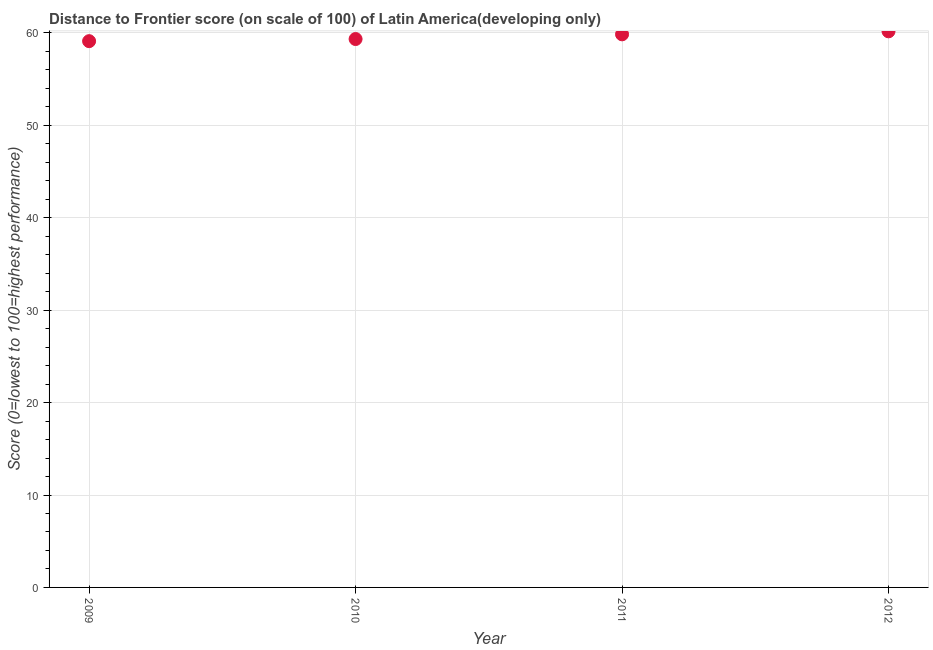What is the distance to frontier score in 2009?
Your answer should be compact. 59.11. Across all years, what is the maximum distance to frontier score?
Your answer should be very brief. 60.17. Across all years, what is the minimum distance to frontier score?
Give a very brief answer. 59.11. In which year was the distance to frontier score minimum?
Provide a short and direct response. 2009. What is the sum of the distance to frontier score?
Your answer should be very brief. 238.46. What is the difference between the distance to frontier score in 2011 and 2012?
Ensure brevity in your answer.  -0.33. What is the average distance to frontier score per year?
Your answer should be compact. 59.62. What is the median distance to frontier score?
Make the answer very short. 59.59. What is the ratio of the distance to frontier score in 2009 to that in 2010?
Offer a terse response. 1. Is the distance to frontier score in 2009 less than that in 2010?
Ensure brevity in your answer.  Yes. What is the difference between the highest and the second highest distance to frontier score?
Your answer should be very brief. 0.33. What is the difference between the highest and the lowest distance to frontier score?
Your answer should be compact. 1.06. Does the distance to frontier score monotonically increase over the years?
Offer a terse response. Yes. Are the values on the major ticks of Y-axis written in scientific E-notation?
Keep it short and to the point. No. What is the title of the graph?
Provide a succinct answer. Distance to Frontier score (on scale of 100) of Latin America(developing only). What is the label or title of the Y-axis?
Your answer should be compact. Score (0=lowest to 100=highest performance). What is the Score (0=lowest to 100=highest performance) in 2009?
Your answer should be compact. 59.11. What is the Score (0=lowest to 100=highest performance) in 2010?
Keep it short and to the point. 59.34. What is the Score (0=lowest to 100=highest performance) in 2011?
Give a very brief answer. 59.85. What is the Score (0=lowest to 100=highest performance) in 2012?
Give a very brief answer. 60.17. What is the difference between the Score (0=lowest to 100=highest performance) in 2009 and 2010?
Give a very brief answer. -0.23. What is the difference between the Score (0=lowest to 100=highest performance) in 2009 and 2011?
Your response must be concise. -0.74. What is the difference between the Score (0=lowest to 100=highest performance) in 2009 and 2012?
Offer a terse response. -1.06. What is the difference between the Score (0=lowest to 100=highest performance) in 2010 and 2011?
Your answer should be very brief. -0.51. What is the difference between the Score (0=lowest to 100=highest performance) in 2010 and 2012?
Keep it short and to the point. -0.83. What is the difference between the Score (0=lowest to 100=highest performance) in 2011 and 2012?
Give a very brief answer. -0.33. What is the ratio of the Score (0=lowest to 100=highest performance) in 2009 to that in 2011?
Give a very brief answer. 0.99. What is the ratio of the Score (0=lowest to 100=highest performance) in 2009 to that in 2012?
Give a very brief answer. 0.98. What is the ratio of the Score (0=lowest to 100=highest performance) in 2010 to that in 2011?
Make the answer very short. 0.99. 